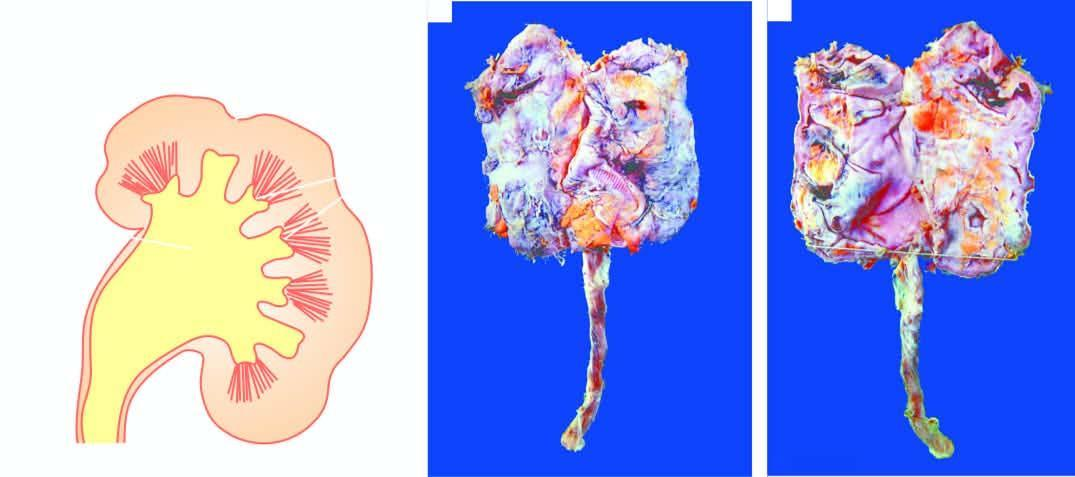s inflammatory cell infiltration contracted kidney in chronic pyelonephritis with calyectasis?
Answer the question using a single word or phrase. No 